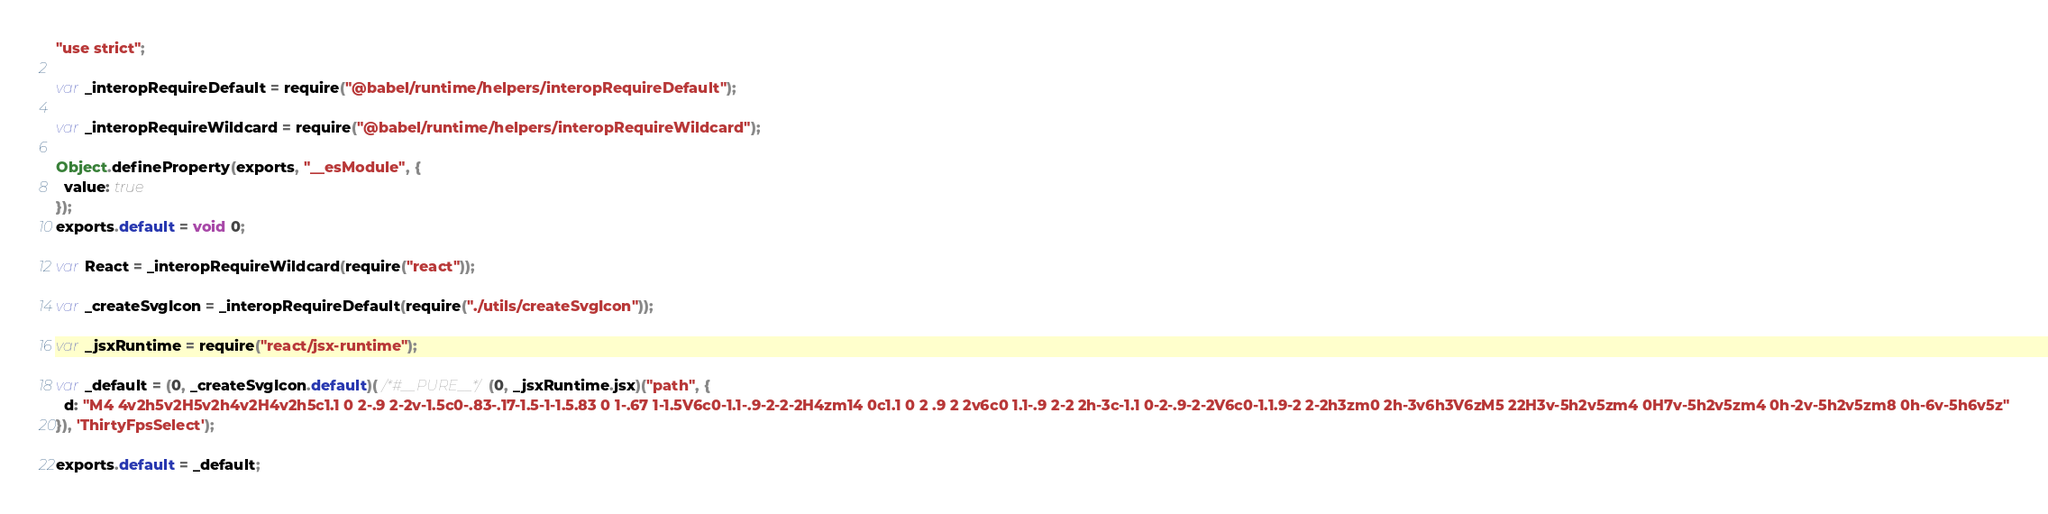Convert code to text. <code><loc_0><loc_0><loc_500><loc_500><_JavaScript_>"use strict";

var _interopRequireDefault = require("@babel/runtime/helpers/interopRequireDefault");

var _interopRequireWildcard = require("@babel/runtime/helpers/interopRequireWildcard");

Object.defineProperty(exports, "__esModule", {
  value: true
});
exports.default = void 0;

var React = _interopRequireWildcard(require("react"));

var _createSvgIcon = _interopRequireDefault(require("./utils/createSvgIcon"));

var _jsxRuntime = require("react/jsx-runtime");

var _default = (0, _createSvgIcon.default)( /*#__PURE__*/(0, _jsxRuntime.jsx)("path", {
  d: "M4 4v2h5v2H5v2h4v2H4v2h5c1.1 0 2-.9 2-2v-1.5c0-.83-.17-1.5-1-1.5.83 0 1-.67 1-1.5V6c0-1.1-.9-2-2-2H4zm14 0c1.1 0 2 .9 2 2v6c0 1.1-.9 2-2 2h-3c-1.1 0-2-.9-2-2V6c0-1.1.9-2 2-2h3zm0 2h-3v6h3V6zM5 22H3v-5h2v5zm4 0H7v-5h2v5zm4 0h-2v-5h2v5zm8 0h-6v-5h6v5z"
}), 'ThirtyFpsSelect');

exports.default = _default;</code> 